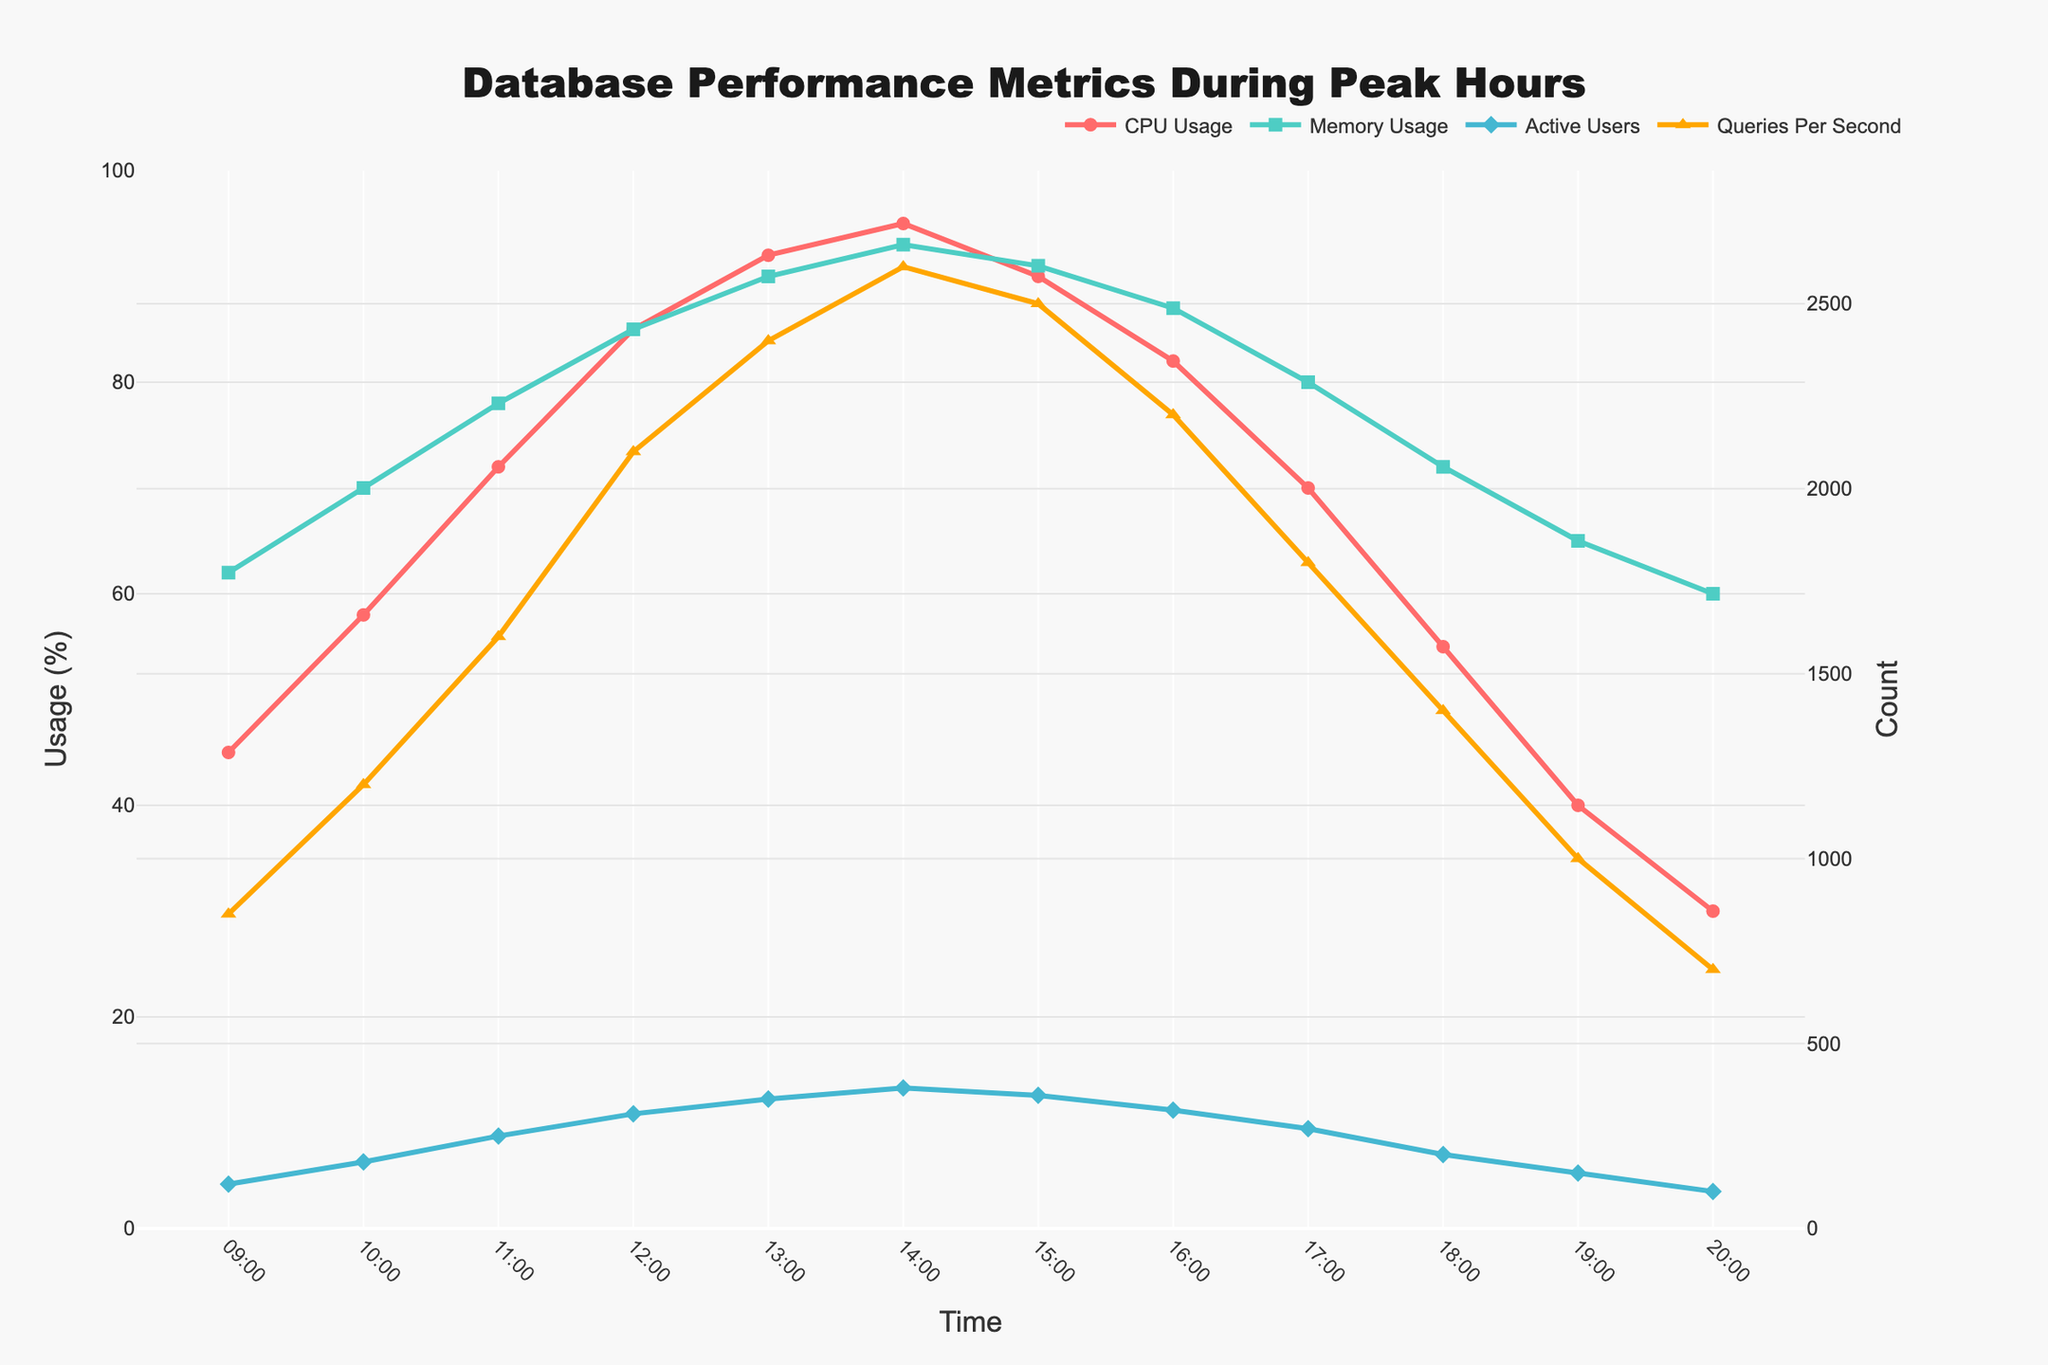What is the peak CPU usage percentage during the recorded time period? Look at the highest point on the CPU Usage (%) line in the chart. The peak CPU usage occurs at 14:00 with a value of 95%.
Answer: 95% At what time is the memory usage the highest, and what is its value? Identify the highest point on the Memory Usage (%) line. The highest point is at 14:00 with a value of 93%.
Answer: 14:00, 93% How does the CPU usage at 10:00 compare to the CPU usage at 16:00? Refer to the CPU Usage (%) line at the specified times. At 10:00, the CPU usage is 58%, while at 16:00, it is 82%. Compare the two values to see that CPU usage at 16:00 is higher than at 10:00.
Answer: Higher at 16:00 What is the difference in the number of active users between 12:00 and 13:00? Check the Active Users line to find the values at 12:00 and 13:00. At 12:00, there are 310 active users, and at 13:00, there are 350 active users. Subtract the two numbers: 350 - 310 = 40.
Answer: 40 Was there ever a time when the memory usage was higher than the CPU usage? If so, when? Compare the two lines for Memory Usage (%) and CPU Usage (%) over the entire time period. At 09:00, memory usage (62%) is higher than CPU usage (45%).
Answer: 09:00 What is the average CPU usage between 12:00 and 17:00? Identify the CPU Usage (%) values from 12:00 to 17:00: 85, 92, 95, 90, 82, 70. Add these values and divide by the number of points: (85 + 92 + 95 + 90 + 82 + 70) / 6 = 514 / 6 ≈ 85.67.
Answer: 85.67% During which hours did the number of queries per second reach its maximum value? Look at the highest point on the Queries Per Second line. The maximum value (2600 queries per second) occurs at 14:00.
Answer: 14:00 Are there any times when the usage patterns of CPU and memory are inversely proportional (one goes up while the other goes down)? Compare the trends of the CPU and Memory Usage (%) lines. There are no clear inversely proportional patterns; both lines generally follow the same increasing and decreasing trends.
Answer: No What is the total increase in the number of active users from 09:00 to 15:00? Check the Active Users values at 09:00 and 15:00. At 09:00, there are 120 users, and at 15:00, there are 360 users. Subtract the initial value from the final value: 360 - 120 = 240.
Answer: 240 Describe the color used to represent the Queries Per Second in the plot Look at the Queries Per Second line in the figure. The color used is orange.
Answer: Orange 